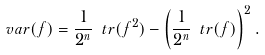<formula> <loc_0><loc_0><loc_500><loc_500>v a r ( f ) = \frac { 1 } { 2 ^ { n } } \ t r ( f ^ { 2 } ) - \left ( \frac { 1 } { 2 ^ { n } } \ t r ( f ) \right ) ^ { 2 } .</formula> 